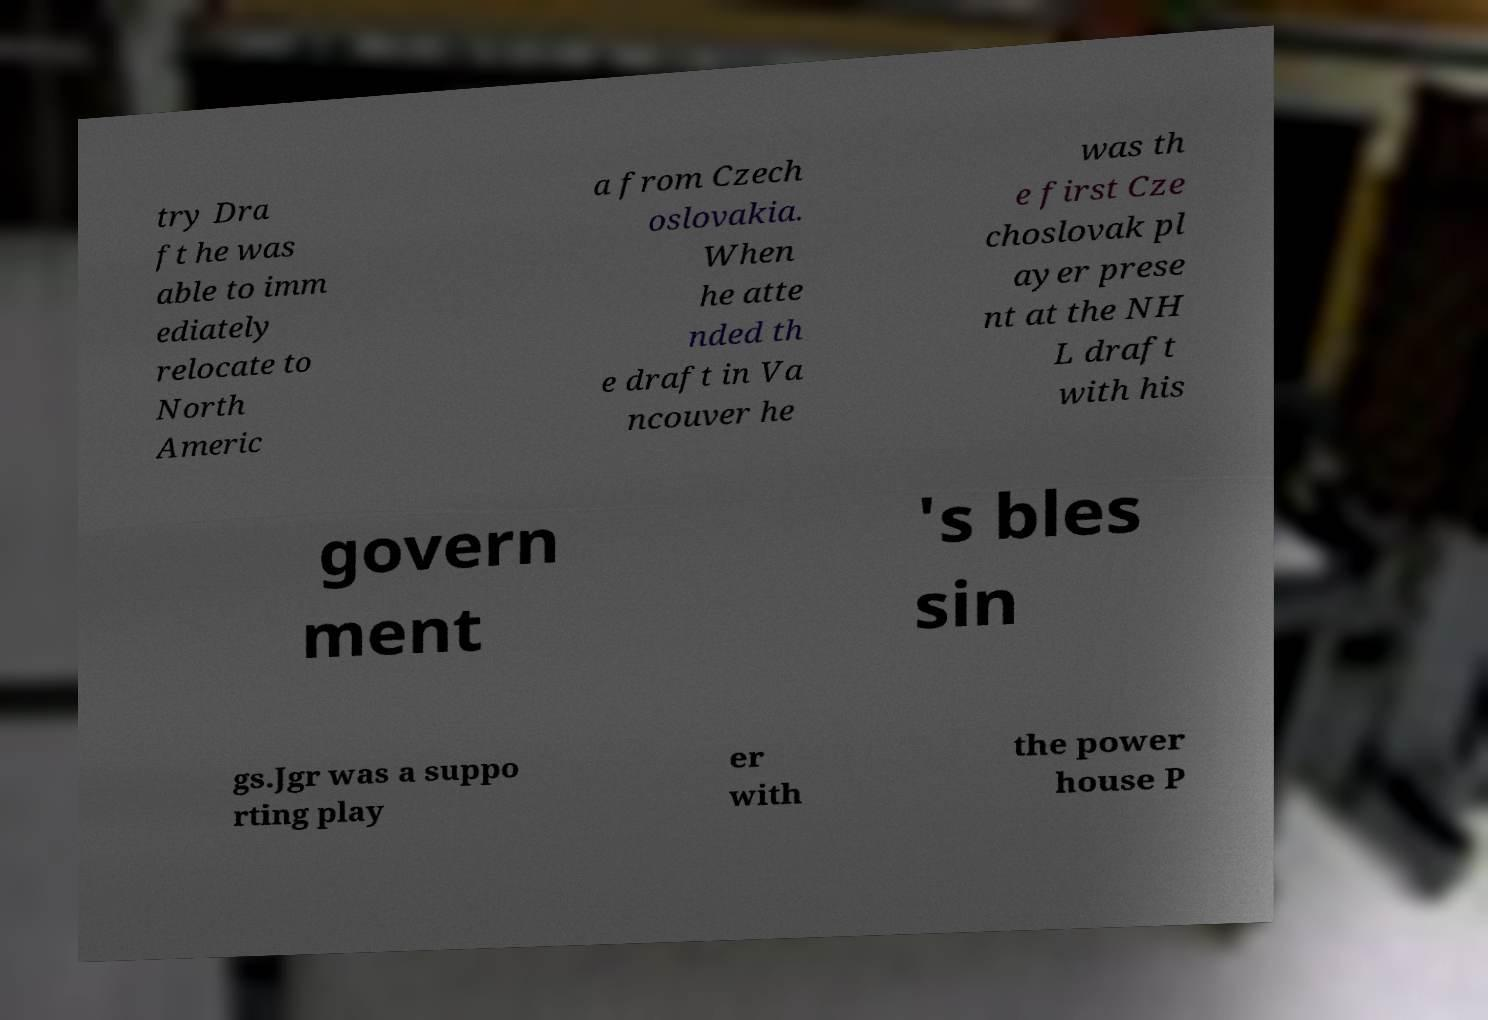Please identify and transcribe the text found in this image. try Dra ft he was able to imm ediately relocate to North Americ a from Czech oslovakia. When he atte nded th e draft in Va ncouver he was th e first Cze choslovak pl ayer prese nt at the NH L draft with his govern ment 's bles sin gs.Jgr was a suppo rting play er with the power house P 